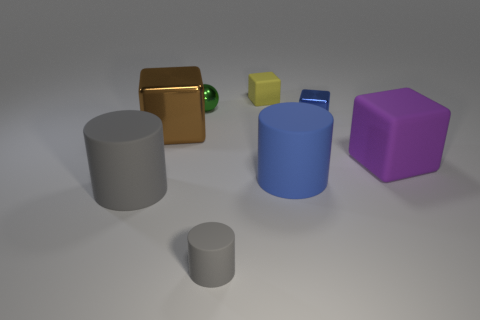Is the big blue matte thing the same shape as the small yellow matte object?
Make the answer very short. No. Is the number of yellow things that are to the right of the tiny blue thing the same as the number of brown shiny objects in front of the blue matte thing?
Make the answer very short. Yes. What is the color of the other tiny block that is the same material as the purple block?
Make the answer very short. Yellow. What number of yellow objects are made of the same material as the large purple cube?
Offer a very short reply. 1. Do the big object that is to the right of the small blue thing and the ball have the same color?
Provide a succinct answer. No. How many small blue objects are the same shape as the brown thing?
Ensure brevity in your answer.  1. Are there an equal number of small matte cylinders that are to the right of the small blue metal thing and tiny blue things?
Give a very brief answer. No. There is a metallic ball that is the same size as the blue block; what is its color?
Your response must be concise. Green. Are there any tiny rubber objects that have the same shape as the large gray matte thing?
Provide a short and direct response. Yes. There is a gray cylinder in front of the large rubber cylinder that is in front of the big cylinder that is right of the small sphere; what is it made of?
Make the answer very short. Rubber. 